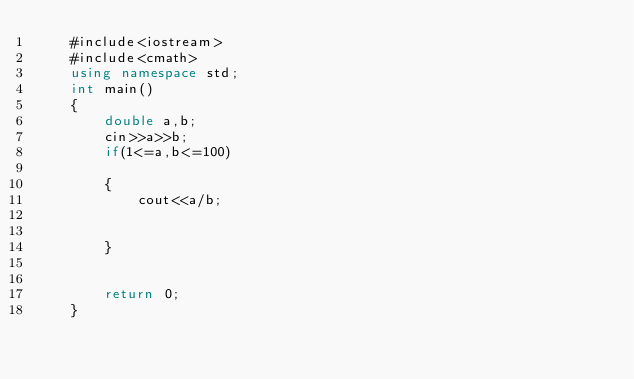Convert code to text. <code><loc_0><loc_0><loc_500><loc_500><_C++_>    #include<iostream>
    #include<cmath>
    using namespace std;
    int main()
    {
        double a,b;
        cin>>a>>b;
        if(1<=a,b<=100)
     
        {
            cout<<a/b;
     
     
        }
     
     
        return 0;
    }</code> 